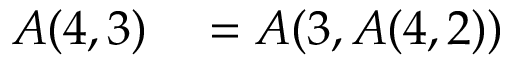<formula> <loc_0><loc_0><loc_500><loc_500>\begin{array} { r l } { A ( 4 , 3 ) } & = A ( 3 , A ( 4 , 2 ) ) } \end{array}</formula> 